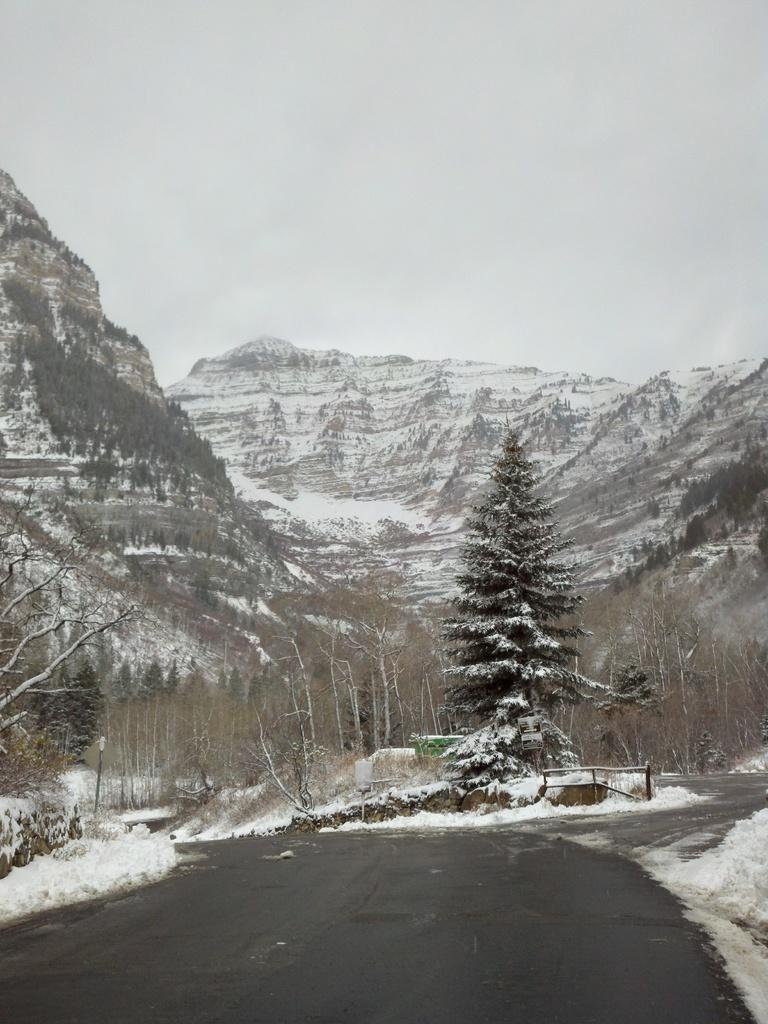What type of pathway can be seen in the image? There is a road in the image. What natural elements are present in the image? There are trees and hills in the image. What man-made structures can be seen in the image? There are poles and a board in the image. What is visible in the background of the image? The sky is visible in the background of the image. What type of cent can be seen interacting with the board in the image? There is no cent present in the image; it features a road, trees, poles, a board, hills, and the sky. What type of camp is visible in the image? There is no camp present in the image. 